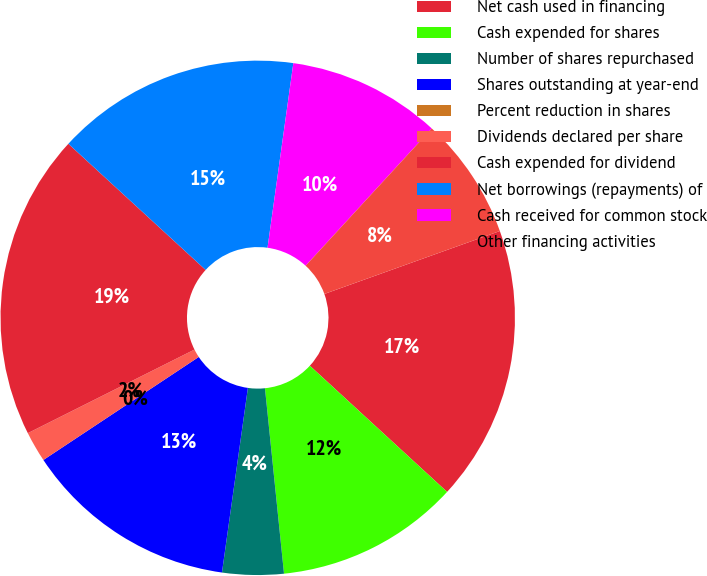<chart> <loc_0><loc_0><loc_500><loc_500><pie_chart><fcel>Net cash used in financing<fcel>Cash expended for shares<fcel>Number of shares repurchased<fcel>Shares outstanding at year-end<fcel>Percent reduction in shares<fcel>Dividends declared per share<fcel>Cash expended for dividend<fcel>Net borrowings (repayments) of<fcel>Cash received for common stock<fcel>Other financing activities<nl><fcel>17.31%<fcel>11.54%<fcel>3.85%<fcel>13.46%<fcel>0.0%<fcel>1.92%<fcel>19.23%<fcel>15.38%<fcel>9.62%<fcel>7.69%<nl></chart> 